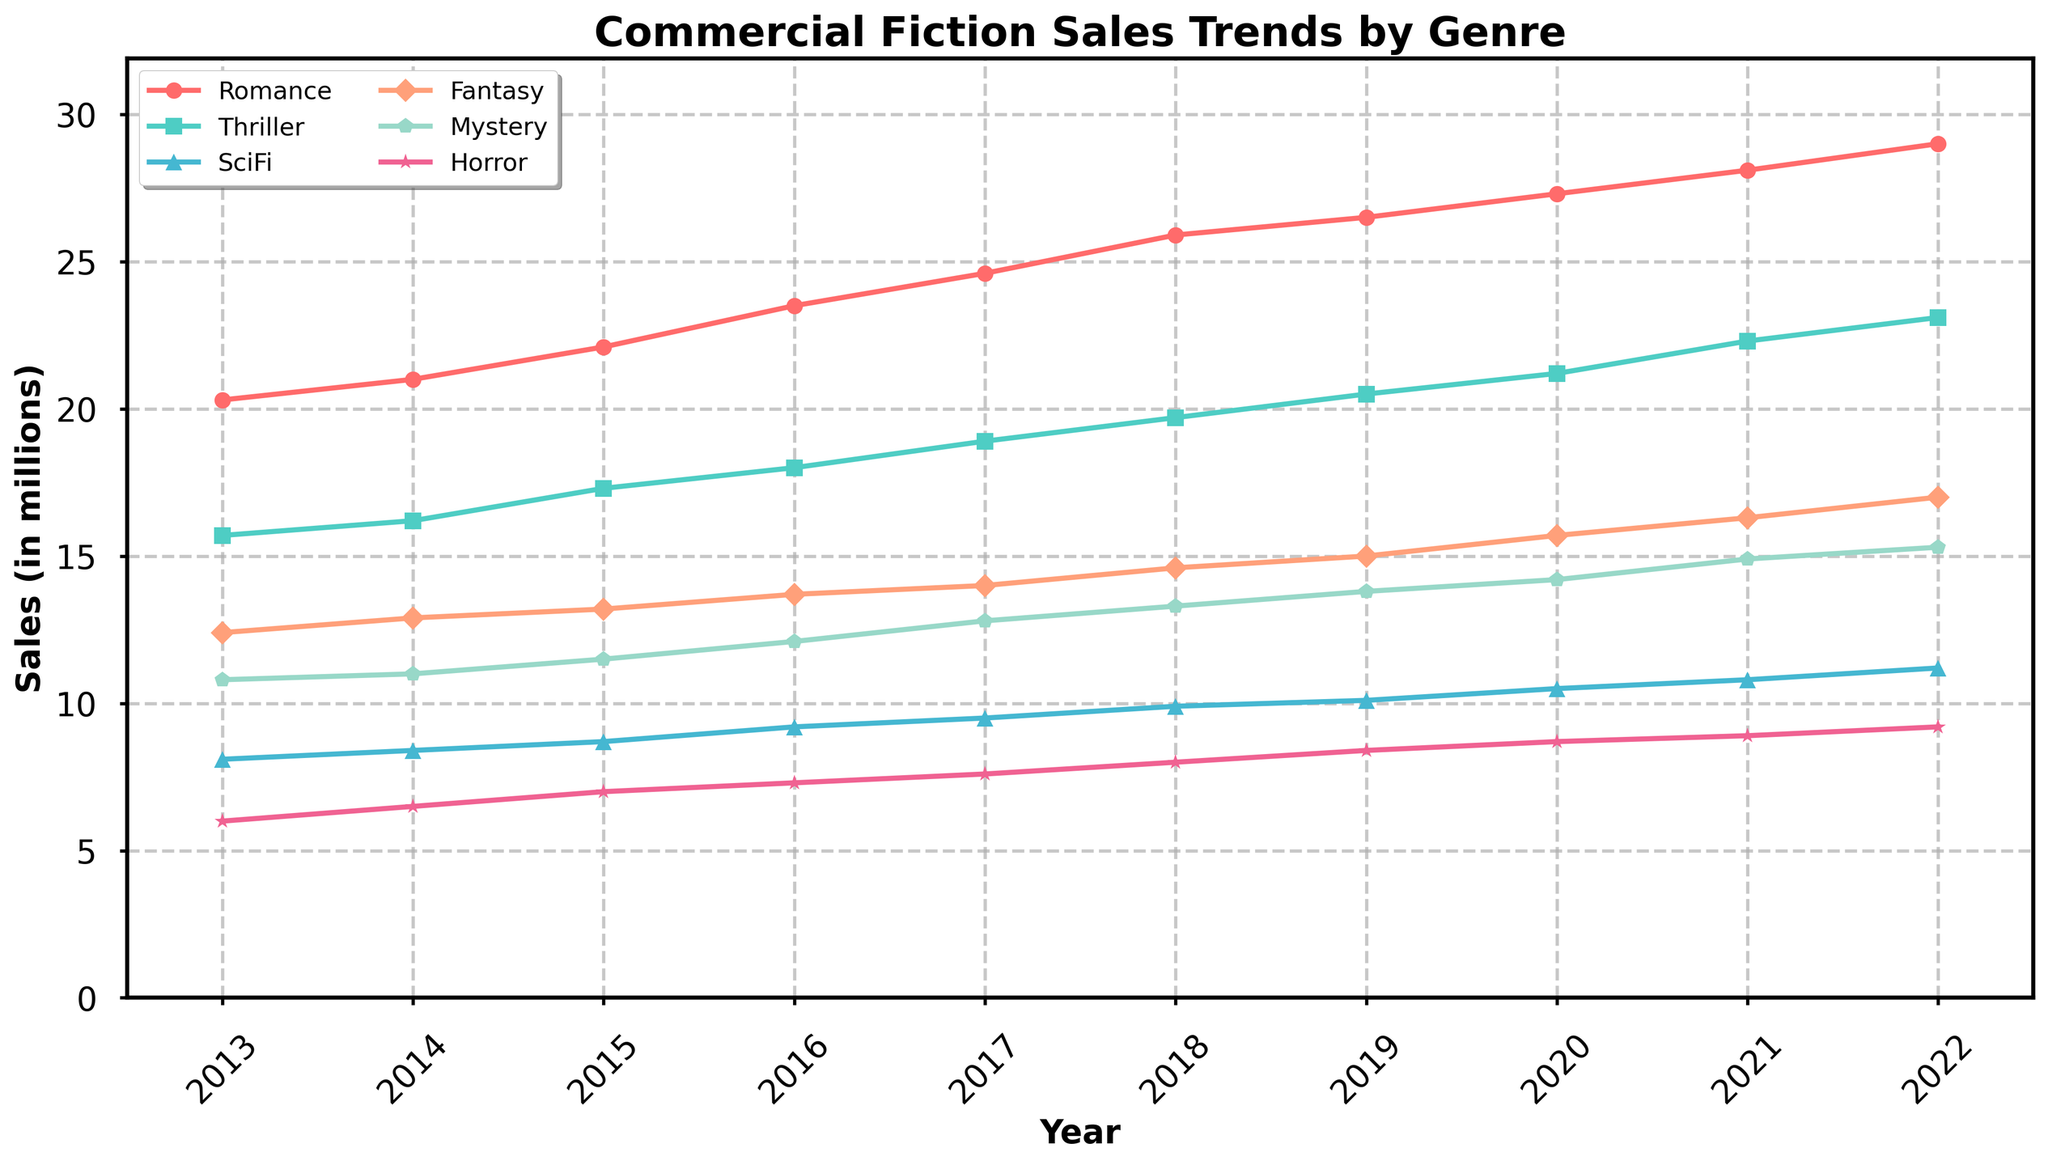what is the title of the plot? The title of the plot is usually found at the top center: it's "Commercial Fiction Sales Trends by Genre."
Answer: Commercial Fiction Sales Trends by Genre What genre had the highest sales in 2022? To find this, we need to look at the 2022 data points for all genres. The highest point in 2022 corresponds to Romance.
Answer: Romance How did Thriller sales compare between 2013 and 2022? Look at the 2013 and 2022 points for Thriller and compare them. In 2013, Thriller sales were at 15.7 million, and in 2022 they were at 23.1 million, so sales increased.
Answer: Increased What was the average sales of the Mystery genre over the decade? Calculate the average by summing up Mystery sales from 2013 to 2022 and then divide by the number of years. (10.8+11.0+11.5+12.1+12.8+13.3+13.8+14.2+14.9+15.3)/10 = 13.47
Answer: 13.47 million Which genre had the least sales in 2017? In 2017, locate the data points for all genres and identify the lowest value. Horror had the least sales with 7.6 million.
Answer: Horror What is the overall trend for SciFi sales from 2013 to 2022? Observe the progression of SciFi sales from 2013 to 2022. The sales exhibit a gradual increase from 8.1 million to 11.2 million.
Answer: Increasing Is there any year where all genres have increased sales compared to the previous year? Compare sales of each genre year over year to check if there's a year where all genres show an increase. From 2019 to 2020, all genres had increased sales.
Answer: 2019 to 2020 How do Fantasy sales in 2016 compare to Romance sales in 2013? Look at the data points for Fantasy in 2016 (13.7 million) and Romance in 2013 (20.3 million) and compare them. Romance sales in 2013 were higher.
Answer: Romance sales in 2013 were higher What genres show a steeper increase in sales from 2013 to 2017? Identify the slopes of the lines for each genre between 2013 and 2017. Romance and Thriller show the steepest inclines.
Answer: Romance and Thriller 